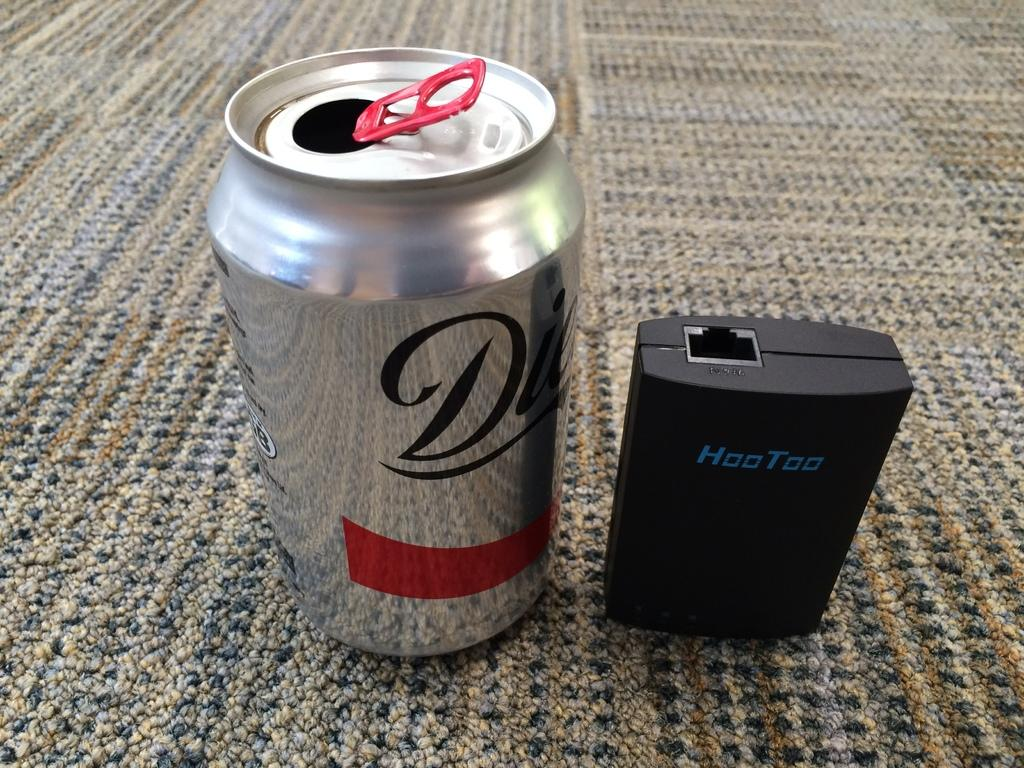Provide a one-sentence caption for the provided image. A can of Diet Coke sits on the floor next to a USB port. 